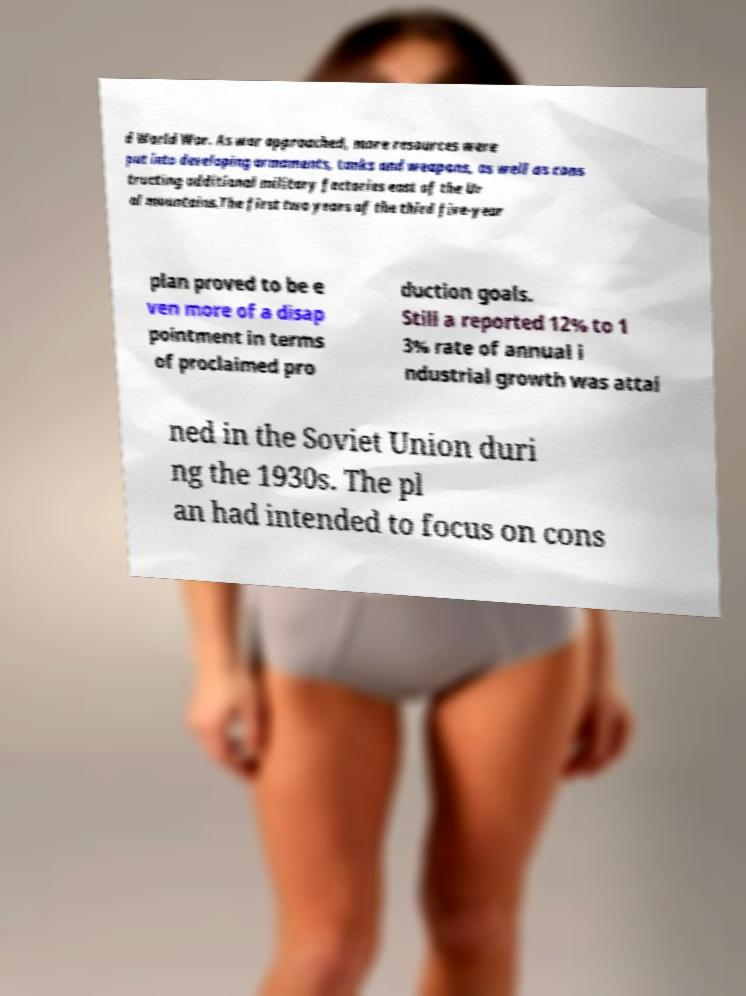I need the written content from this picture converted into text. Can you do that? d World War. As war approached, more resources were put into developing armaments, tanks and weapons, as well as cons tructing additional military factories east of the Ur al mountains.The first two years of the third five-year plan proved to be e ven more of a disap pointment in terms of proclaimed pro duction goals. Still a reported 12% to 1 3% rate of annual i ndustrial growth was attai ned in the Soviet Union duri ng the 1930s. The pl an had intended to focus on cons 